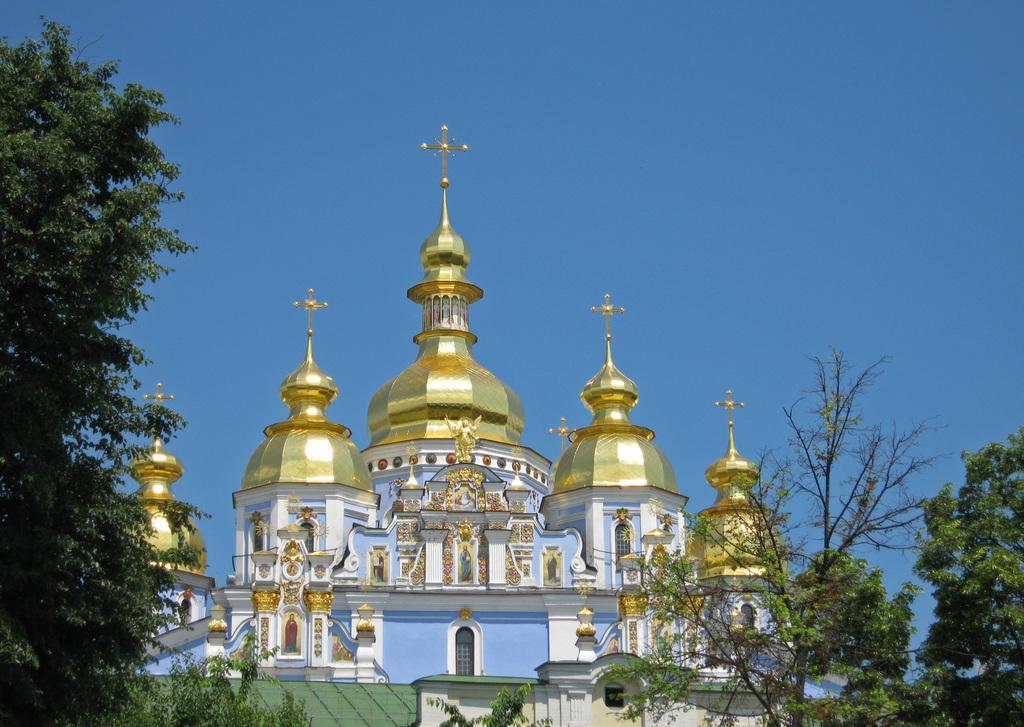What type of natural elements can be seen in the image? There are trees in the image. What type of man-made structures are present in the image? Ancient architecture is present in the image. What type of artistic objects can be seen in the image? There are statues in the image. What is visible in the background of the image? The sky is visible in the background of the image. What is the color of the sky in the image? The color of the sky is blue. How many frogs are sitting on the ancient architecture in the image? There are no frogs present in the image. What emotion is expressed by the statues in the image? The statues in the image do not express emotions, as they are inanimate objects. 